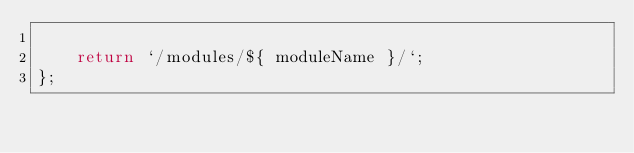<code> <loc_0><loc_0><loc_500><loc_500><_JavaScript_>
    return `/modules/${ moduleName }/`;
};
</code> 